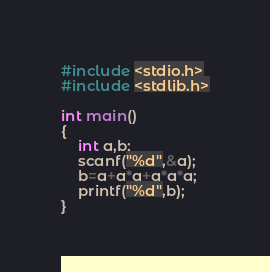Convert code to text. <code><loc_0><loc_0><loc_500><loc_500><_C_>#include <stdio.h>
#include <stdlib.h>

int main()
{
    int a,b;
    scanf("%d",&a);
    b=a+a*a+a*a*a;
    printf("%d",b);
}
</code> 